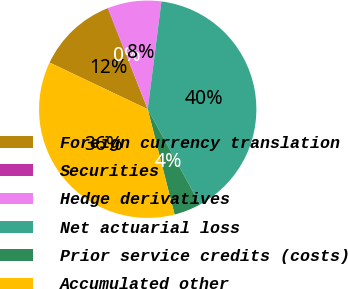Convert chart to OTSL. <chart><loc_0><loc_0><loc_500><loc_500><pie_chart><fcel>Foreign currency translation<fcel>Securities<fcel>Hedge derivatives<fcel>Net actuarial loss<fcel>Prior service credits (costs)<fcel>Accumulated other<nl><fcel>11.91%<fcel>0.08%<fcel>7.96%<fcel>39.99%<fcel>4.02%<fcel>36.04%<nl></chart> 